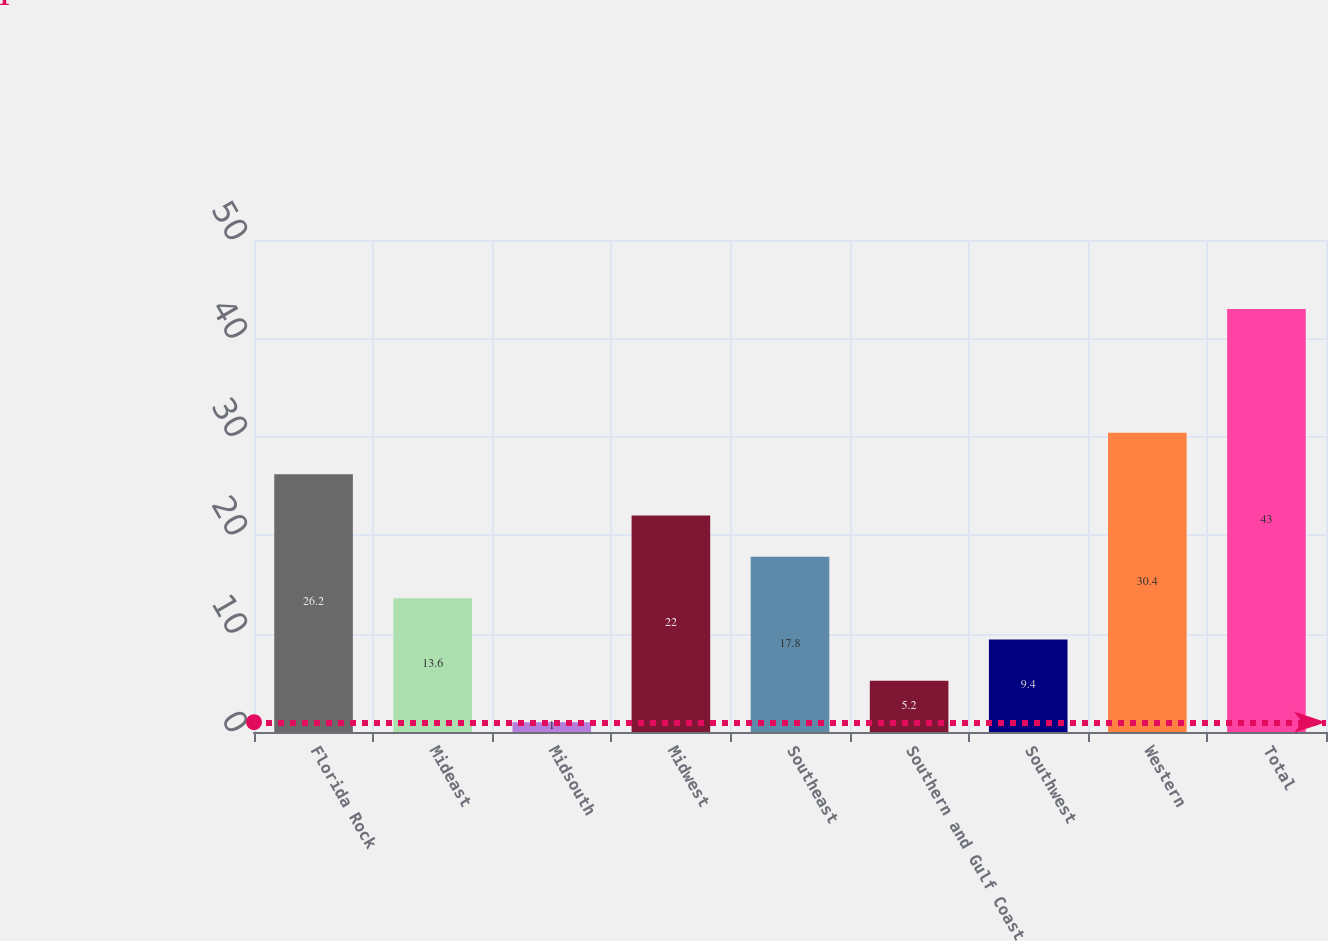Convert chart to OTSL. <chart><loc_0><loc_0><loc_500><loc_500><bar_chart><fcel>Florida Rock<fcel>Mideast<fcel>Midsouth<fcel>Midwest<fcel>Southeast<fcel>Southern and Gulf Coast<fcel>Southwest<fcel>Western<fcel>Total<nl><fcel>26.2<fcel>13.6<fcel>1<fcel>22<fcel>17.8<fcel>5.2<fcel>9.4<fcel>30.4<fcel>43<nl></chart> 